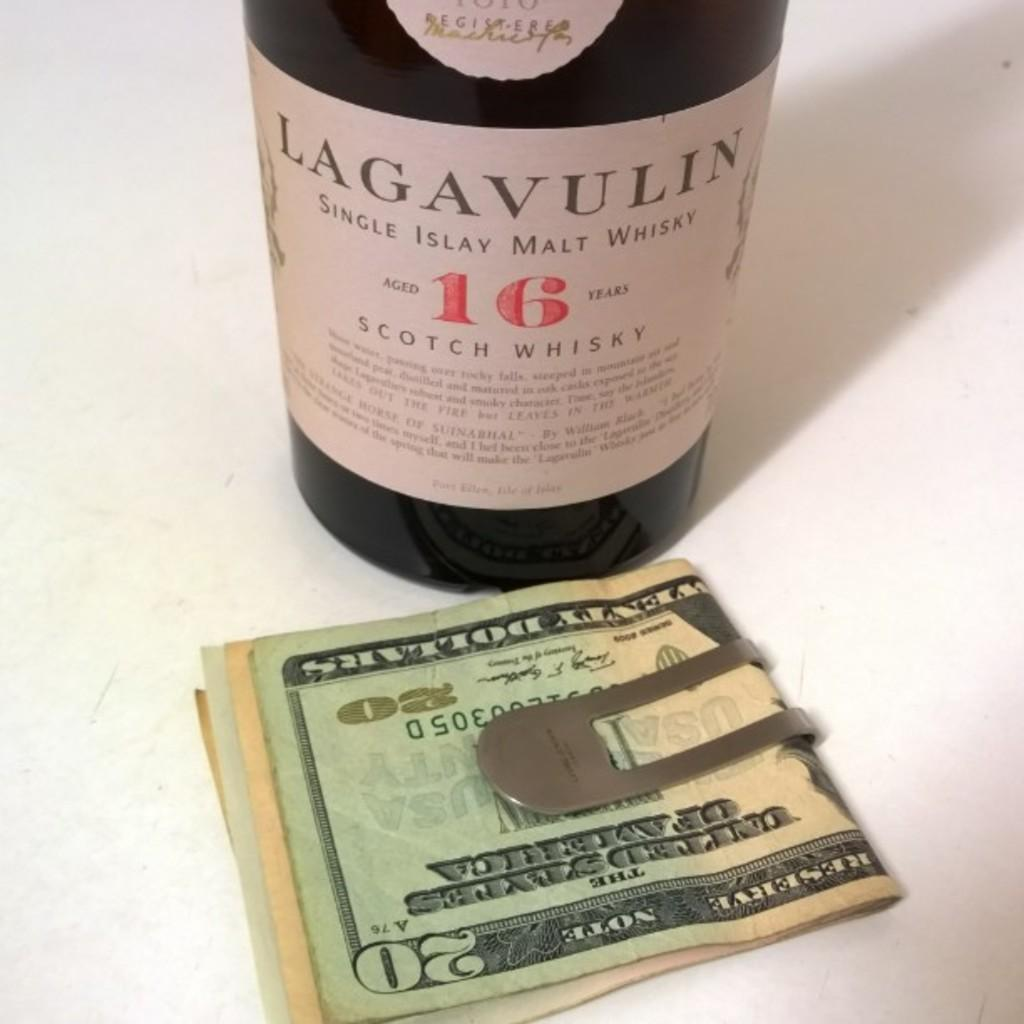<image>
Describe the image concisely. A bottle of Lagavulin scotch whisky sits near a money clip. 